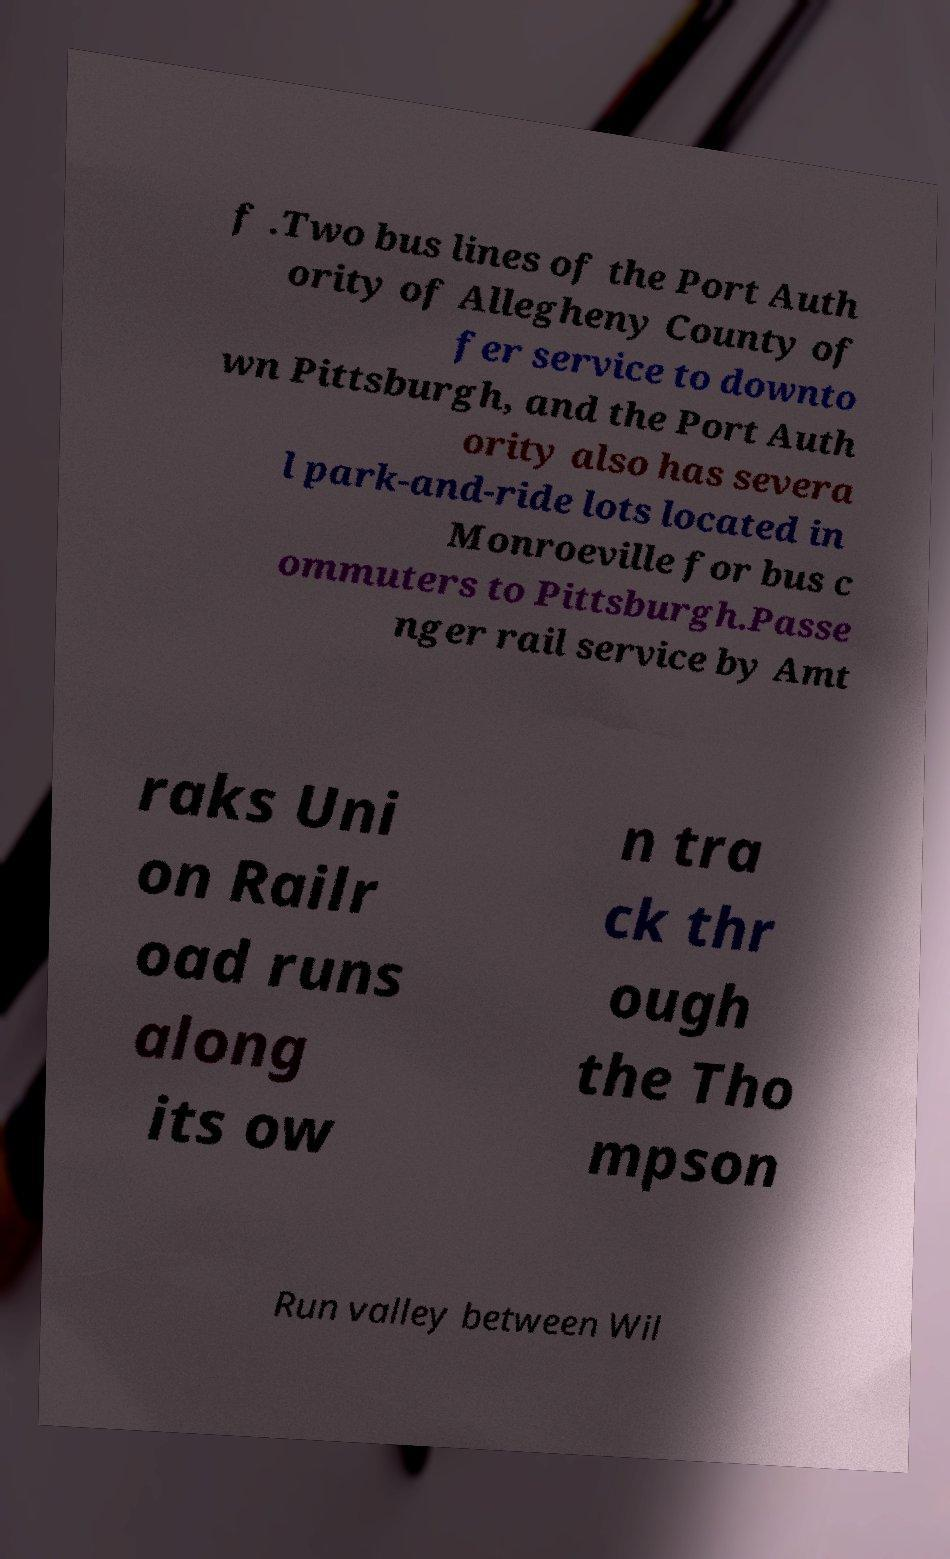Could you assist in decoding the text presented in this image and type it out clearly? f .Two bus lines of the Port Auth ority of Allegheny County of fer service to downto wn Pittsburgh, and the Port Auth ority also has severa l park-and-ride lots located in Monroeville for bus c ommuters to Pittsburgh.Passe nger rail service by Amt raks Uni on Railr oad runs along its ow n tra ck thr ough the Tho mpson Run valley between Wil 